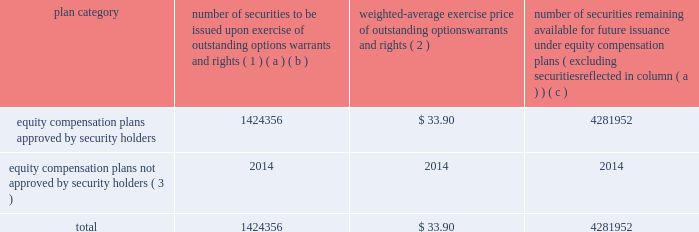Equity compensation plan information the table presents the equity securities available for issuance under our equity compensation plans as of december 31 , 2015 .
Equity compensation plan information plan category number of securities to be issued upon exercise of outstanding options , warrants and rights ( 1 ) weighted-average exercise price of outstanding options , warrants and rights ( 2 ) number of securities remaining available for future issuance under equity compensation plans ( excluding securities reflected in column ( a ) ) ( a ) ( b ) ( c ) equity compensation plans approved by security holders 1424356 $ 33.90 4281952 equity compensation plans not approved by security holders ( 3 ) 2014 2014 2014 .
( 1 ) includes grants made under the huntington ingalls industries , inc .
2012 long-term incentive stock plan ( the "2012 plan" ) , which was approved by our stockholders on may 2 , 2012 , and the huntington ingalls industries , inc .
2011 long-term incentive stock plan ( the "2011 plan" ) , which was approved by the sole stockholder of hii prior to its spin-off from northrop grumman corporation .
Of these shares , 533397 were subject to stock options and 54191 were stock rights granted under the 2011 plan .
In addition , this number includes 35553 stock rights , 10279 restricted stock rights , and 790936 restricted performance stock rights granted under the 2012 plan , assuming target performance achievement .
( 2 ) this is the weighted average exercise price of the 533397 outstanding stock options only .
( 3 ) there are no awards made under plans not approved by security holders .
Item 13 .
Certain relationships and related transactions , and director independence information as to certain relationships and related transactions and director independence will be incorporated herein by reference to the proxy statement for our 2016 annual meeting of stockholders , to be filed within 120 days after the end of the company 2019s fiscal year .
Item 14 .
Principal accountant fees and services information as to principal accountant fees and services will be incorporated herein by reference to the proxy statement for our 2016 annual meeting of stockholders , to be filed within 120 days after the end of the company 2019s fiscal year. .
What is the value of the number of securities to be issued on december 312015? 
Computations: (1424356 * 33.90)
Answer: 48285668.4. 